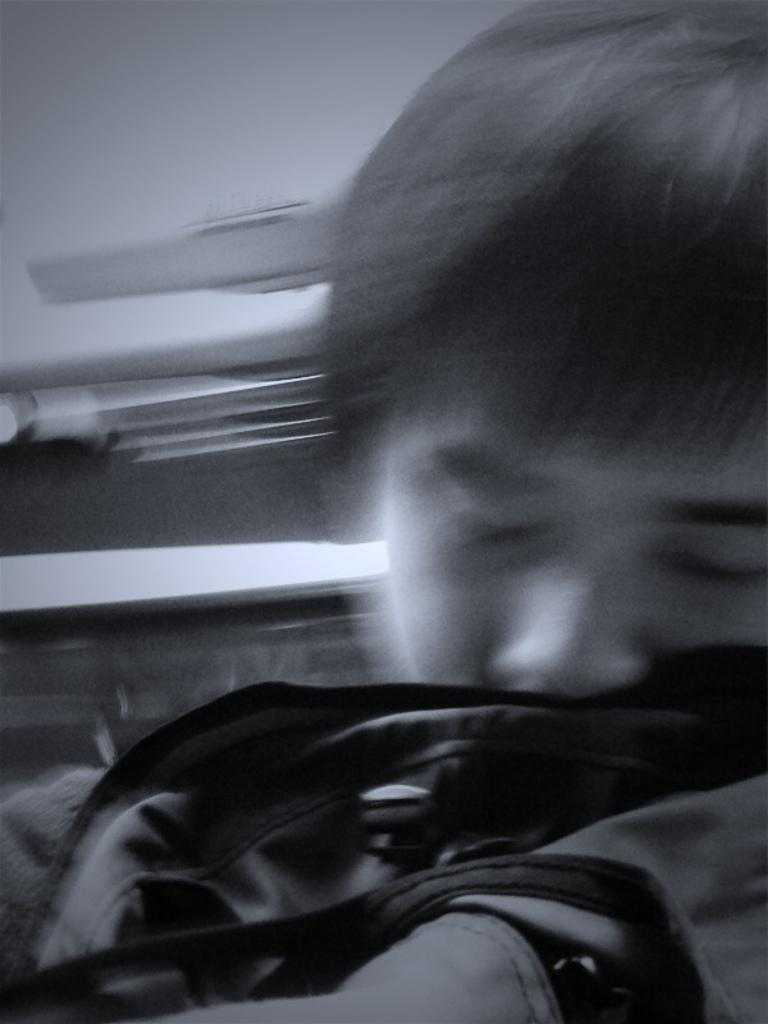What is present in the image? There is a man in the image. What can be seen in the background of the image? There is a wall in the background of the image. What type of zephyr can be seen in the image? There is no zephyr present in the image. What bursts in the image? There is no bursting action depicted in the image. 